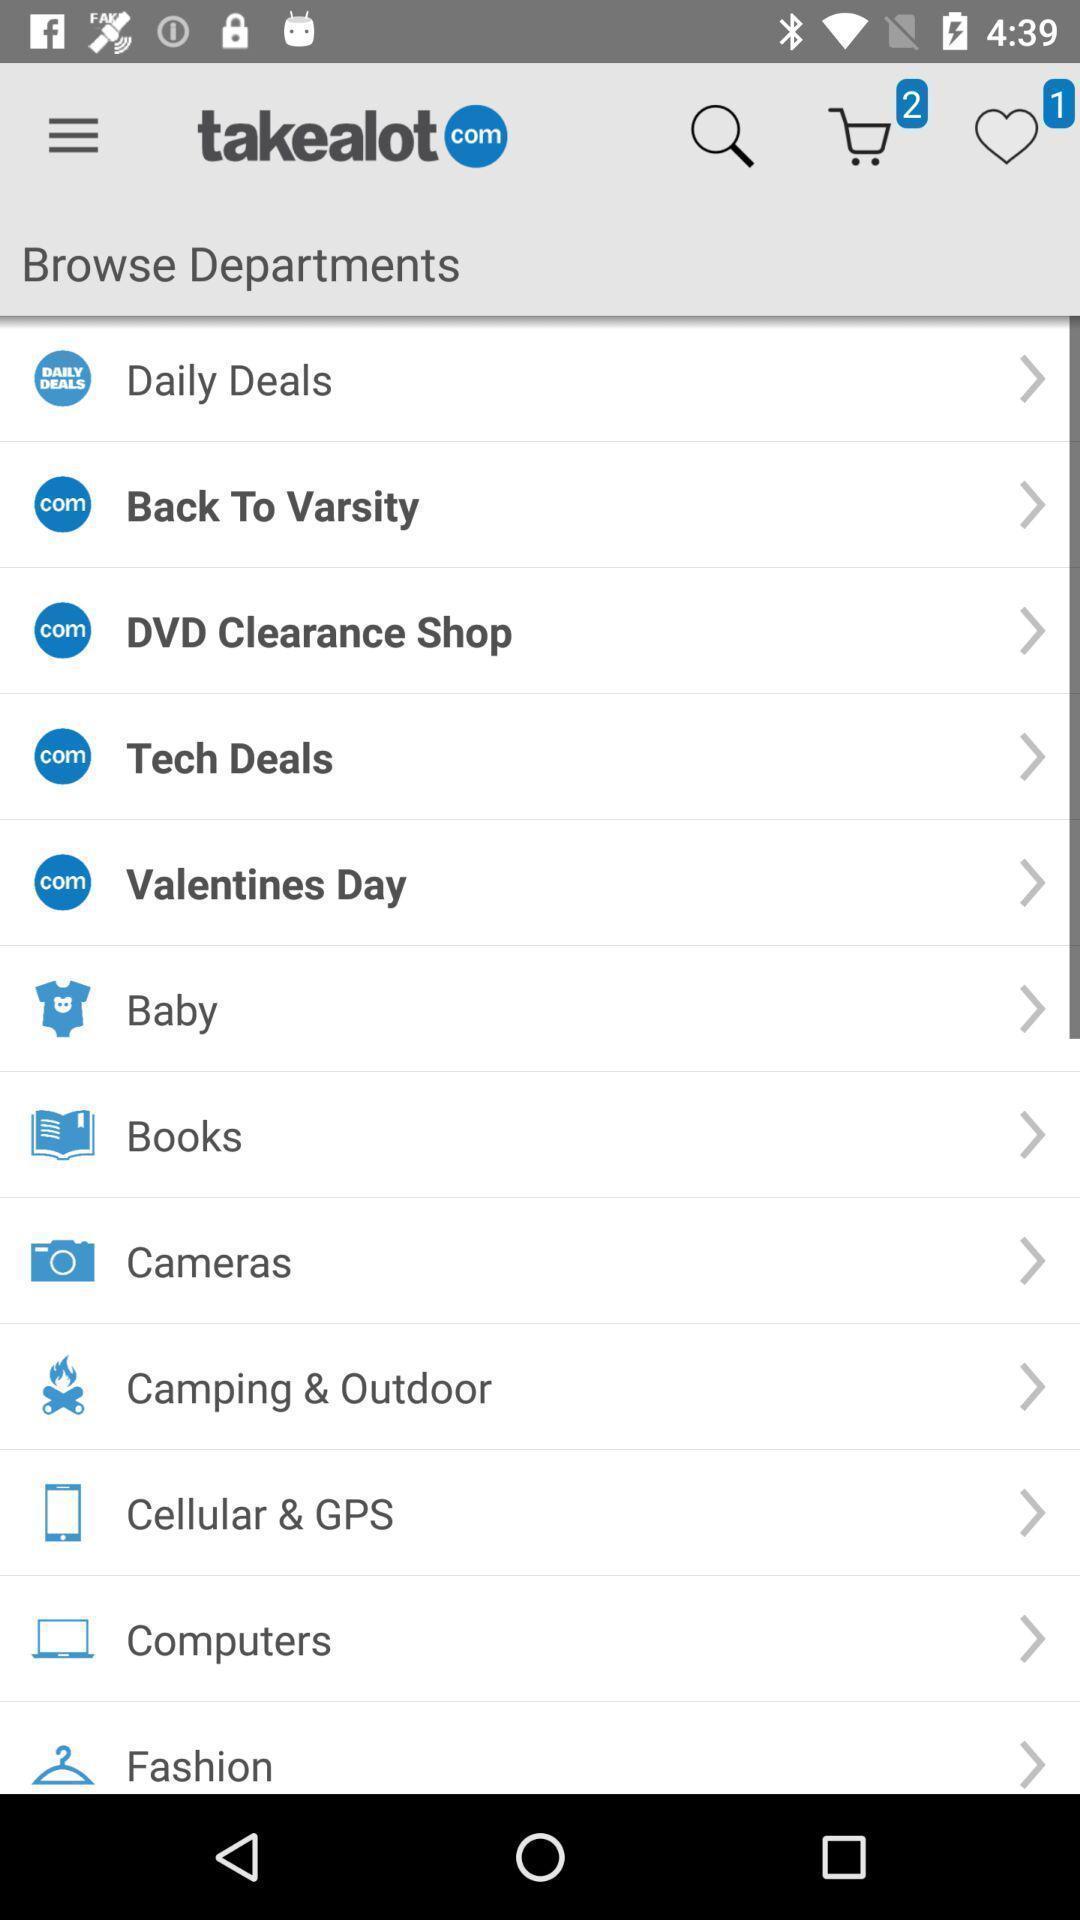Describe the visual elements of this screenshot. Page showing multiple departments. 